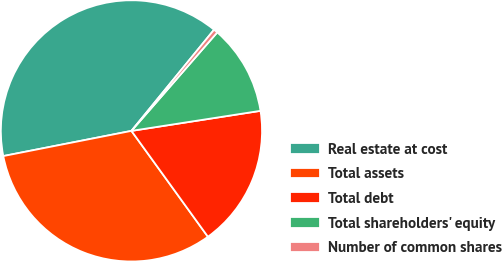Convert chart to OTSL. <chart><loc_0><loc_0><loc_500><loc_500><pie_chart><fcel>Real estate at cost<fcel>Total assets<fcel>Total debt<fcel>Total shareholders' equity<fcel>Number of common shares<nl><fcel>38.99%<fcel>31.87%<fcel>17.5%<fcel>11.14%<fcel>0.51%<nl></chart> 